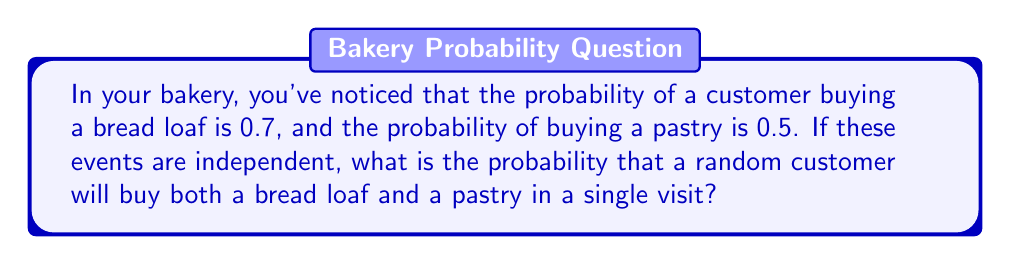Help me with this question. Let's approach this step-by-step:

1) Let A be the event of buying a bread loaf, and B be the event of buying a pastry.

2) We're given:
   P(A) = 0.7 (probability of buying a bread loaf)
   P(B) = 0.5 (probability of buying a pastry)

3) We need to find P(A and B), the probability of both events occurring.

4) Since the events are independent, we can use the multiplication rule of probability:

   For independent events A and B: P(A and B) = P(A) × P(B)

5) Substituting the values:

   P(A and B) = 0.7 × 0.5

6) Calculate:

   P(A and B) = 0.35

Therefore, the probability that a random customer will buy both a bread loaf and a pastry in a single visit is 0.35 or 35%.
Answer: 0.35 